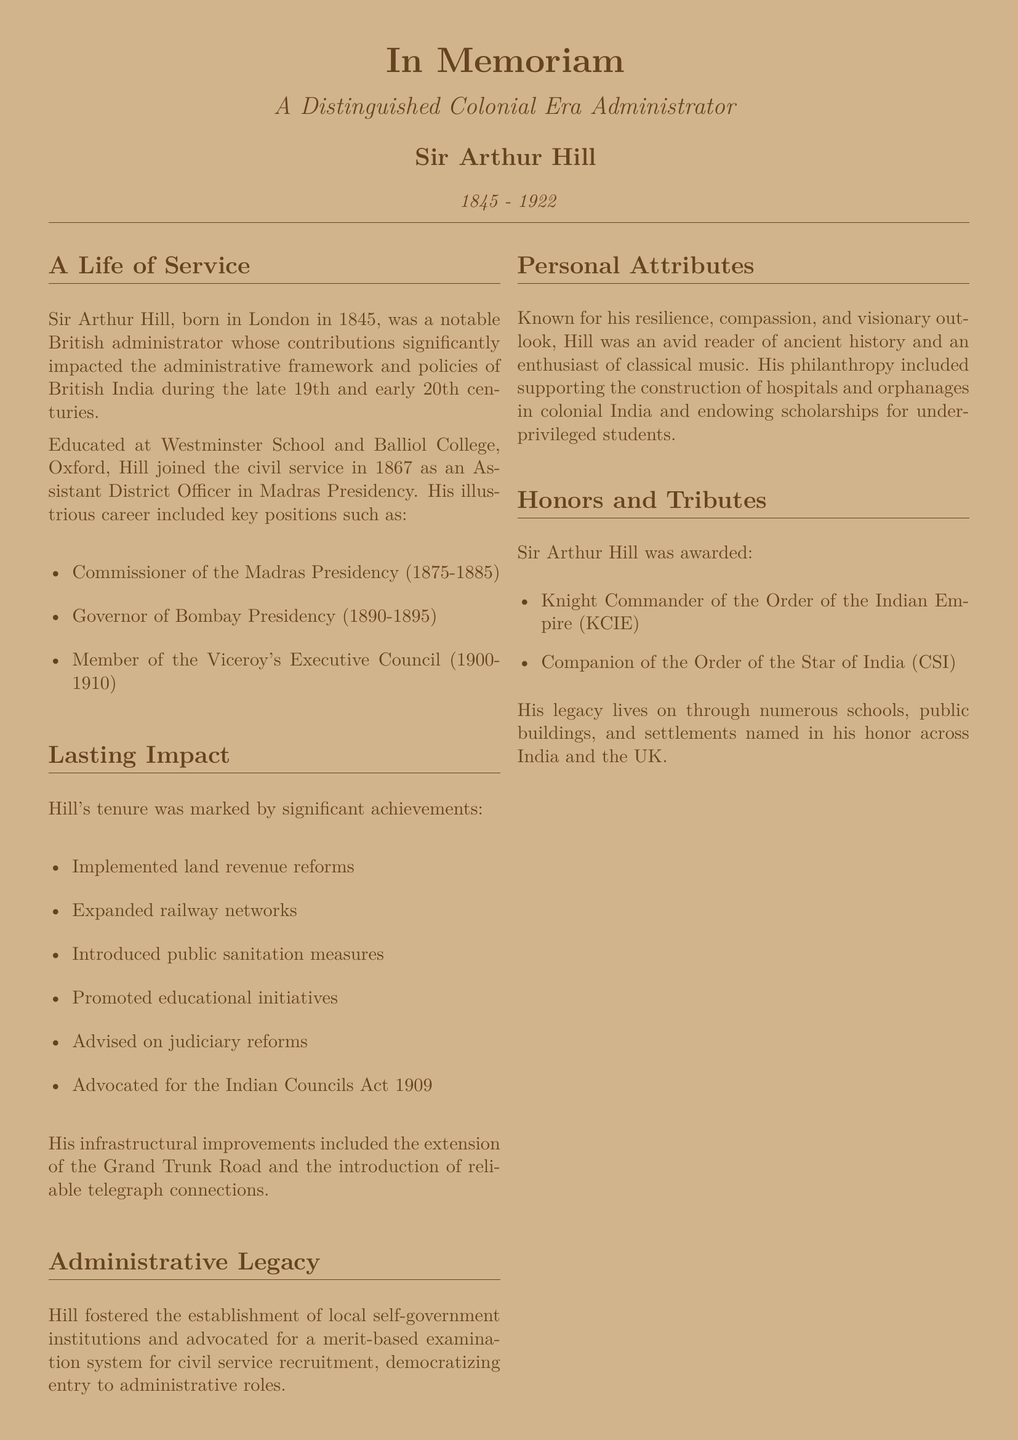What was the birth year of Sir Arthur Hill? The document states that Sir Arthur Hill was born in London in 1845.
Answer: 1845 What position did Sir Arthur Hill hold from 1890 to 1895? The document mentions he was the Governor of Bombay Presidency during that time.
Answer: Governor of Bombay Presidency In which year did Sir Arthur Hill pass away? The document notes that he passed away in 1922.
Answer: 1922 What major reform did Hill implement related to land management? The document highlights that he implemented land revenue reforms.
Answer: Land revenue reforms Which act did Hill advocate for in 1909? The document states that he advocated for the Indian Councils Act 1909.
Answer: Indian Councils Act 1909 What significant infrastructure project did Hill extend? The document indicates that he extended the Grand Trunk Road.
Answer: Grand Trunk Road What was one of Hill's personal attributes mentioned in the obituary? The document describes him as resilient, compassionate, and visionary.
Answer: Resilient What honor was awarded to Sir Arthur Hill by the Order of the Indian Empire? The document lists that he was made a Knight Commander of the Order of the Indian Empire.
Answer: Knight Commander of the Order of the Indian Empire What type of governance system did Hill advocate for in civil service recruitment? The document states he advocated for a merit-based examination system.
Answer: Merit-based examination system 